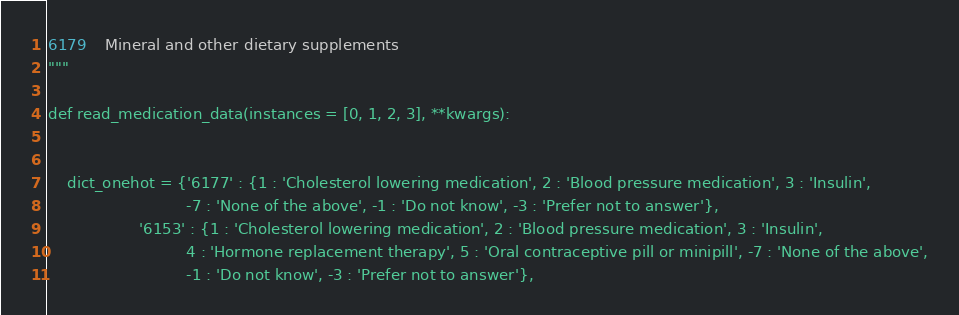Convert code to text. <code><loc_0><loc_0><loc_500><loc_500><_Python_>6179	Mineral and other dietary supplements
"""

def read_medication_data(instances = [0, 1, 2, 3], **kwargs):


    dict_onehot = {'6177' : {1 : 'Cholesterol lowering medication', 2 : 'Blood pressure medication', 3 : 'Insulin',
                             -7 : 'None of the above', -1 : 'Do not know', -3 : 'Prefer not to answer'},
                   '6153' : {1 : 'Cholesterol lowering medication', 2 : 'Blood pressure medication', 3 : 'Insulin',
                             4 : 'Hormone replacement therapy', 5 : 'Oral contraceptive pill or minipill', -7 : 'None of the above',
                             -1 : 'Do not know', -3 : 'Prefer not to answer'},</code> 